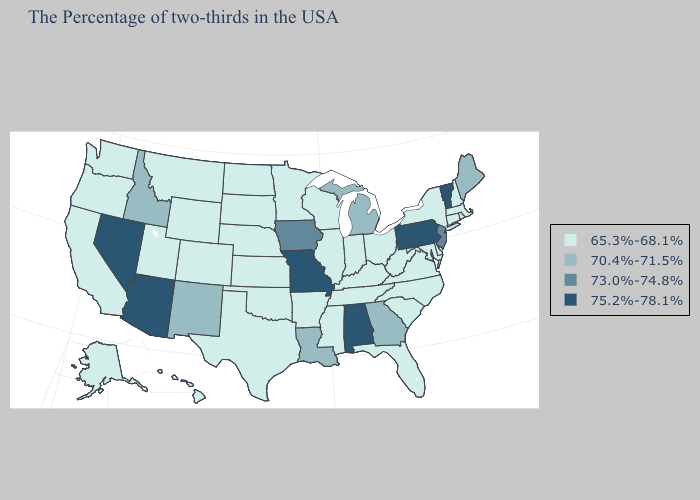Which states have the highest value in the USA?
Be succinct. Vermont, Pennsylvania, Alabama, Missouri, Arizona, Nevada. Does the map have missing data?
Write a very short answer. No. Name the states that have a value in the range 65.3%-68.1%?
Give a very brief answer. Massachusetts, Rhode Island, New Hampshire, Connecticut, New York, Delaware, Maryland, Virginia, North Carolina, South Carolina, West Virginia, Ohio, Florida, Kentucky, Indiana, Tennessee, Wisconsin, Illinois, Mississippi, Arkansas, Minnesota, Kansas, Nebraska, Oklahoma, Texas, South Dakota, North Dakota, Wyoming, Colorado, Utah, Montana, California, Washington, Oregon, Alaska, Hawaii. Name the states that have a value in the range 75.2%-78.1%?
Give a very brief answer. Vermont, Pennsylvania, Alabama, Missouri, Arizona, Nevada. What is the lowest value in the West?
Write a very short answer. 65.3%-68.1%. What is the value of Wyoming?
Short answer required. 65.3%-68.1%. Among the states that border Iowa , which have the highest value?
Give a very brief answer. Missouri. What is the lowest value in states that border Illinois?
Give a very brief answer. 65.3%-68.1%. Does Louisiana have a lower value than Connecticut?
Concise answer only. No. What is the value of Arizona?
Keep it brief. 75.2%-78.1%. Name the states that have a value in the range 73.0%-74.8%?
Give a very brief answer. New Jersey, Iowa. How many symbols are there in the legend?
Short answer required. 4. What is the value of Vermont?
Write a very short answer. 75.2%-78.1%. Name the states that have a value in the range 75.2%-78.1%?
Quick response, please. Vermont, Pennsylvania, Alabama, Missouri, Arizona, Nevada. What is the lowest value in the USA?
Give a very brief answer. 65.3%-68.1%. 